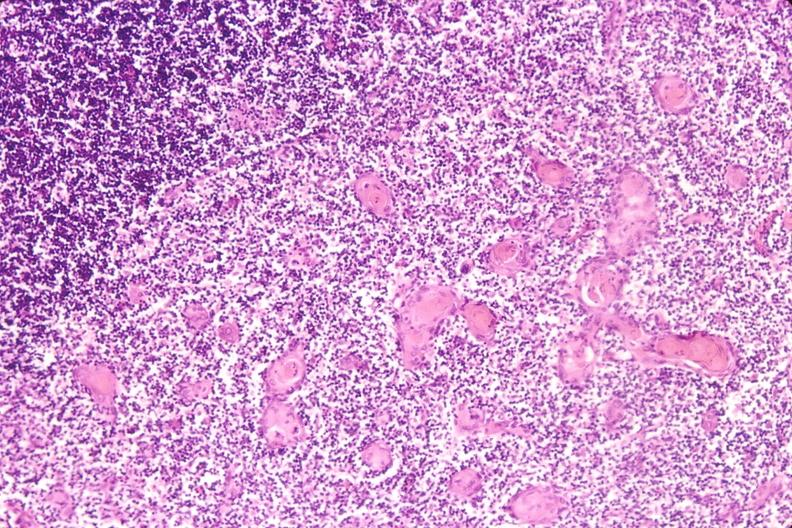what do thymus , stress induce?
Answer the question using a single word or phrase. Involution in baby with hyaline membrane disease 